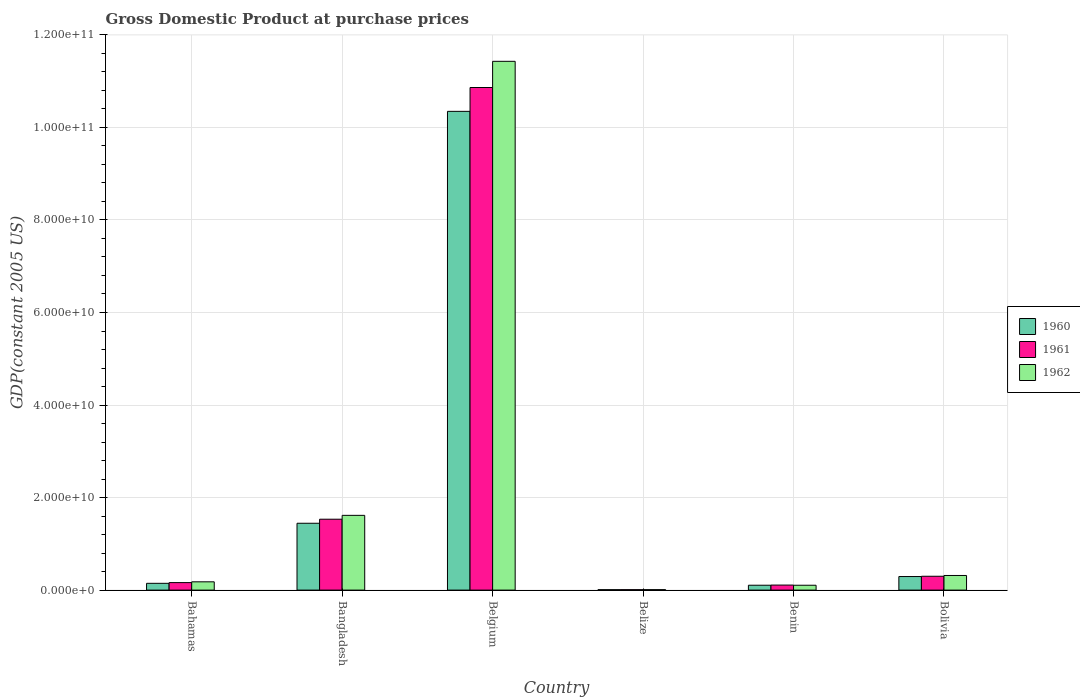How many different coloured bars are there?
Provide a succinct answer. 3. How many groups of bars are there?
Your answer should be very brief. 6. Are the number of bars per tick equal to the number of legend labels?
Make the answer very short. Yes. How many bars are there on the 3rd tick from the left?
Provide a succinct answer. 3. In how many cases, is the number of bars for a given country not equal to the number of legend labels?
Keep it short and to the point. 0. What is the GDP at purchase prices in 1960 in Bangladesh?
Your answer should be compact. 1.44e+1. Across all countries, what is the maximum GDP at purchase prices in 1962?
Provide a succinct answer. 1.14e+11. Across all countries, what is the minimum GDP at purchase prices in 1960?
Keep it short and to the point. 8.94e+07. In which country was the GDP at purchase prices in 1960 maximum?
Make the answer very short. Belgium. In which country was the GDP at purchase prices in 1962 minimum?
Offer a very short reply. Belize. What is the total GDP at purchase prices in 1962 in the graph?
Offer a terse response. 1.37e+11. What is the difference between the GDP at purchase prices in 1960 in Belize and that in Benin?
Keep it short and to the point. -9.64e+08. What is the difference between the GDP at purchase prices in 1960 in Belize and the GDP at purchase prices in 1962 in Bahamas?
Keep it short and to the point. -1.70e+09. What is the average GDP at purchase prices in 1962 per country?
Ensure brevity in your answer.  2.28e+1. What is the difference between the GDP at purchase prices of/in 1960 and GDP at purchase prices of/in 1961 in Belize?
Make the answer very short. -4.38e+06. What is the ratio of the GDP at purchase prices in 1961 in Belize to that in Benin?
Your response must be concise. 0.09. Is the difference between the GDP at purchase prices in 1960 in Bahamas and Bangladesh greater than the difference between the GDP at purchase prices in 1961 in Bahamas and Bangladesh?
Give a very brief answer. Yes. What is the difference between the highest and the second highest GDP at purchase prices in 1960?
Your response must be concise. -8.90e+1. What is the difference between the highest and the lowest GDP at purchase prices in 1962?
Keep it short and to the point. 1.14e+11. Is the sum of the GDP at purchase prices in 1961 in Belize and Bolivia greater than the maximum GDP at purchase prices in 1960 across all countries?
Make the answer very short. No. What does the 2nd bar from the left in Bolivia represents?
Your answer should be compact. 1961. Are all the bars in the graph horizontal?
Your answer should be compact. No. Are the values on the major ticks of Y-axis written in scientific E-notation?
Give a very brief answer. Yes. Does the graph contain any zero values?
Provide a succinct answer. No. How are the legend labels stacked?
Give a very brief answer. Vertical. What is the title of the graph?
Provide a succinct answer. Gross Domestic Product at purchase prices. Does "2008" appear as one of the legend labels in the graph?
Offer a terse response. No. What is the label or title of the X-axis?
Ensure brevity in your answer.  Country. What is the label or title of the Y-axis?
Your answer should be compact. GDP(constant 2005 US). What is the GDP(constant 2005 US) in 1960 in Bahamas?
Provide a short and direct response. 1.47e+09. What is the GDP(constant 2005 US) of 1961 in Bahamas?
Offer a very short reply. 1.62e+09. What is the GDP(constant 2005 US) of 1962 in Bahamas?
Give a very brief answer. 1.79e+09. What is the GDP(constant 2005 US) of 1960 in Bangladesh?
Your response must be concise. 1.44e+1. What is the GDP(constant 2005 US) in 1961 in Bangladesh?
Provide a succinct answer. 1.53e+1. What is the GDP(constant 2005 US) in 1962 in Bangladesh?
Offer a terse response. 1.62e+1. What is the GDP(constant 2005 US) of 1960 in Belgium?
Your answer should be compact. 1.03e+11. What is the GDP(constant 2005 US) of 1961 in Belgium?
Provide a succinct answer. 1.09e+11. What is the GDP(constant 2005 US) in 1962 in Belgium?
Make the answer very short. 1.14e+11. What is the GDP(constant 2005 US) of 1960 in Belize?
Keep it short and to the point. 8.94e+07. What is the GDP(constant 2005 US) in 1961 in Belize?
Ensure brevity in your answer.  9.38e+07. What is the GDP(constant 2005 US) of 1962 in Belize?
Your answer should be very brief. 9.84e+07. What is the GDP(constant 2005 US) of 1960 in Benin?
Ensure brevity in your answer.  1.05e+09. What is the GDP(constant 2005 US) in 1961 in Benin?
Give a very brief answer. 1.09e+09. What is the GDP(constant 2005 US) in 1962 in Benin?
Your answer should be very brief. 1.05e+09. What is the GDP(constant 2005 US) in 1960 in Bolivia?
Keep it short and to the point. 2.93e+09. What is the GDP(constant 2005 US) of 1961 in Bolivia?
Keep it short and to the point. 2.99e+09. What is the GDP(constant 2005 US) in 1962 in Bolivia?
Provide a succinct answer. 3.16e+09. Across all countries, what is the maximum GDP(constant 2005 US) of 1960?
Your response must be concise. 1.03e+11. Across all countries, what is the maximum GDP(constant 2005 US) in 1961?
Offer a terse response. 1.09e+11. Across all countries, what is the maximum GDP(constant 2005 US) in 1962?
Your answer should be compact. 1.14e+11. Across all countries, what is the minimum GDP(constant 2005 US) in 1960?
Provide a succinct answer. 8.94e+07. Across all countries, what is the minimum GDP(constant 2005 US) in 1961?
Provide a succinct answer. 9.38e+07. Across all countries, what is the minimum GDP(constant 2005 US) of 1962?
Offer a very short reply. 9.84e+07. What is the total GDP(constant 2005 US) of 1960 in the graph?
Make the answer very short. 1.23e+11. What is the total GDP(constant 2005 US) in 1961 in the graph?
Your answer should be very brief. 1.30e+11. What is the total GDP(constant 2005 US) of 1962 in the graph?
Your response must be concise. 1.37e+11. What is the difference between the GDP(constant 2005 US) in 1960 in Bahamas and that in Bangladesh?
Your answer should be compact. -1.30e+1. What is the difference between the GDP(constant 2005 US) in 1961 in Bahamas and that in Bangladesh?
Your answer should be very brief. -1.37e+1. What is the difference between the GDP(constant 2005 US) of 1962 in Bahamas and that in Bangladesh?
Your answer should be compact. -1.44e+1. What is the difference between the GDP(constant 2005 US) in 1960 in Bahamas and that in Belgium?
Keep it short and to the point. -1.02e+11. What is the difference between the GDP(constant 2005 US) of 1961 in Bahamas and that in Belgium?
Offer a very short reply. -1.07e+11. What is the difference between the GDP(constant 2005 US) of 1962 in Bahamas and that in Belgium?
Provide a succinct answer. -1.12e+11. What is the difference between the GDP(constant 2005 US) in 1960 in Bahamas and that in Belize?
Your answer should be compact. 1.38e+09. What is the difference between the GDP(constant 2005 US) in 1961 in Bahamas and that in Belize?
Your response must be concise. 1.53e+09. What is the difference between the GDP(constant 2005 US) in 1962 in Bahamas and that in Belize?
Give a very brief answer. 1.69e+09. What is the difference between the GDP(constant 2005 US) of 1960 in Bahamas and that in Benin?
Keep it short and to the point. 4.13e+08. What is the difference between the GDP(constant 2005 US) in 1961 in Bahamas and that in Benin?
Ensure brevity in your answer.  5.36e+08. What is the difference between the GDP(constant 2005 US) in 1962 in Bahamas and that in Benin?
Provide a succinct answer. 7.43e+08. What is the difference between the GDP(constant 2005 US) of 1960 in Bahamas and that in Bolivia?
Provide a short and direct response. -1.47e+09. What is the difference between the GDP(constant 2005 US) of 1961 in Bahamas and that in Bolivia?
Make the answer very short. -1.37e+09. What is the difference between the GDP(constant 2005 US) in 1962 in Bahamas and that in Bolivia?
Give a very brief answer. -1.37e+09. What is the difference between the GDP(constant 2005 US) of 1960 in Bangladesh and that in Belgium?
Ensure brevity in your answer.  -8.90e+1. What is the difference between the GDP(constant 2005 US) of 1961 in Bangladesh and that in Belgium?
Your answer should be very brief. -9.33e+1. What is the difference between the GDP(constant 2005 US) in 1962 in Bangladesh and that in Belgium?
Make the answer very short. -9.81e+1. What is the difference between the GDP(constant 2005 US) in 1960 in Bangladesh and that in Belize?
Offer a terse response. 1.44e+1. What is the difference between the GDP(constant 2005 US) in 1961 in Bangladesh and that in Belize?
Give a very brief answer. 1.52e+1. What is the difference between the GDP(constant 2005 US) of 1962 in Bangladesh and that in Belize?
Keep it short and to the point. 1.61e+1. What is the difference between the GDP(constant 2005 US) in 1960 in Bangladesh and that in Benin?
Provide a short and direct response. 1.34e+1. What is the difference between the GDP(constant 2005 US) of 1961 in Bangladesh and that in Benin?
Keep it short and to the point. 1.42e+1. What is the difference between the GDP(constant 2005 US) in 1962 in Bangladesh and that in Benin?
Make the answer very short. 1.51e+1. What is the difference between the GDP(constant 2005 US) of 1960 in Bangladesh and that in Bolivia?
Make the answer very short. 1.15e+1. What is the difference between the GDP(constant 2005 US) in 1961 in Bangladesh and that in Bolivia?
Offer a very short reply. 1.23e+1. What is the difference between the GDP(constant 2005 US) of 1962 in Bangladesh and that in Bolivia?
Your answer should be very brief. 1.30e+1. What is the difference between the GDP(constant 2005 US) in 1960 in Belgium and that in Belize?
Provide a succinct answer. 1.03e+11. What is the difference between the GDP(constant 2005 US) in 1961 in Belgium and that in Belize?
Provide a short and direct response. 1.09e+11. What is the difference between the GDP(constant 2005 US) in 1962 in Belgium and that in Belize?
Keep it short and to the point. 1.14e+11. What is the difference between the GDP(constant 2005 US) of 1960 in Belgium and that in Benin?
Your answer should be very brief. 1.02e+11. What is the difference between the GDP(constant 2005 US) in 1961 in Belgium and that in Benin?
Provide a short and direct response. 1.08e+11. What is the difference between the GDP(constant 2005 US) in 1962 in Belgium and that in Benin?
Your response must be concise. 1.13e+11. What is the difference between the GDP(constant 2005 US) of 1960 in Belgium and that in Bolivia?
Ensure brevity in your answer.  1.01e+11. What is the difference between the GDP(constant 2005 US) in 1961 in Belgium and that in Bolivia?
Your answer should be compact. 1.06e+11. What is the difference between the GDP(constant 2005 US) in 1962 in Belgium and that in Bolivia?
Give a very brief answer. 1.11e+11. What is the difference between the GDP(constant 2005 US) of 1960 in Belize and that in Benin?
Offer a terse response. -9.64e+08. What is the difference between the GDP(constant 2005 US) of 1961 in Belize and that in Benin?
Provide a short and direct response. -9.92e+08. What is the difference between the GDP(constant 2005 US) in 1962 in Belize and that in Benin?
Offer a very short reply. -9.50e+08. What is the difference between the GDP(constant 2005 US) of 1960 in Belize and that in Bolivia?
Provide a short and direct response. -2.84e+09. What is the difference between the GDP(constant 2005 US) of 1961 in Belize and that in Bolivia?
Offer a very short reply. -2.90e+09. What is the difference between the GDP(constant 2005 US) of 1962 in Belize and that in Bolivia?
Make the answer very short. -3.06e+09. What is the difference between the GDP(constant 2005 US) in 1960 in Benin and that in Bolivia?
Your answer should be very brief. -1.88e+09. What is the difference between the GDP(constant 2005 US) of 1961 in Benin and that in Bolivia?
Your answer should be very brief. -1.91e+09. What is the difference between the GDP(constant 2005 US) of 1962 in Benin and that in Bolivia?
Offer a terse response. -2.11e+09. What is the difference between the GDP(constant 2005 US) in 1960 in Bahamas and the GDP(constant 2005 US) in 1961 in Bangladesh?
Ensure brevity in your answer.  -1.39e+1. What is the difference between the GDP(constant 2005 US) of 1960 in Bahamas and the GDP(constant 2005 US) of 1962 in Bangladesh?
Ensure brevity in your answer.  -1.47e+1. What is the difference between the GDP(constant 2005 US) in 1961 in Bahamas and the GDP(constant 2005 US) in 1962 in Bangladesh?
Ensure brevity in your answer.  -1.45e+1. What is the difference between the GDP(constant 2005 US) of 1960 in Bahamas and the GDP(constant 2005 US) of 1961 in Belgium?
Ensure brevity in your answer.  -1.07e+11. What is the difference between the GDP(constant 2005 US) in 1960 in Bahamas and the GDP(constant 2005 US) in 1962 in Belgium?
Your response must be concise. -1.13e+11. What is the difference between the GDP(constant 2005 US) in 1961 in Bahamas and the GDP(constant 2005 US) in 1962 in Belgium?
Provide a succinct answer. -1.13e+11. What is the difference between the GDP(constant 2005 US) in 1960 in Bahamas and the GDP(constant 2005 US) in 1961 in Belize?
Your response must be concise. 1.37e+09. What is the difference between the GDP(constant 2005 US) in 1960 in Bahamas and the GDP(constant 2005 US) in 1962 in Belize?
Your answer should be compact. 1.37e+09. What is the difference between the GDP(constant 2005 US) of 1961 in Bahamas and the GDP(constant 2005 US) of 1962 in Belize?
Provide a succinct answer. 1.52e+09. What is the difference between the GDP(constant 2005 US) in 1960 in Bahamas and the GDP(constant 2005 US) in 1961 in Benin?
Provide a short and direct response. 3.79e+08. What is the difference between the GDP(constant 2005 US) in 1960 in Bahamas and the GDP(constant 2005 US) in 1962 in Benin?
Offer a terse response. 4.17e+08. What is the difference between the GDP(constant 2005 US) in 1961 in Bahamas and the GDP(constant 2005 US) in 1962 in Benin?
Your answer should be very brief. 5.73e+08. What is the difference between the GDP(constant 2005 US) in 1960 in Bahamas and the GDP(constant 2005 US) in 1961 in Bolivia?
Keep it short and to the point. -1.53e+09. What is the difference between the GDP(constant 2005 US) in 1960 in Bahamas and the GDP(constant 2005 US) in 1962 in Bolivia?
Keep it short and to the point. -1.69e+09. What is the difference between the GDP(constant 2005 US) of 1961 in Bahamas and the GDP(constant 2005 US) of 1962 in Bolivia?
Provide a succinct answer. -1.54e+09. What is the difference between the GDP(constant 2005 US) of 1960 in Bangladesh and the GDP(constant 2005 US) of 1961 in Belgium?
Provide a succinct answer. -9.42e+1. What is the difference between the GDP(constant 2005 US) of 1960 in Bangladesh and the GDP(constant 2005 US) of 1962 in Belgium?
Offer a terse response. -9.98e+1. What is the difference between the GDP(constant 2005 US) in 1961 in Bangladesh and the GDP(constant 2005 US) in 1962 in Belgium?
Provide a succinct answer. -9.90e+1. What is the difference between the GDP(constant 2005 US) of 1960 in Bangladesh and the GDP(constant 2005 US) of 1961 in Belize?
Provide a succinct answer. 1.44e+1. What is the difference between the GDP(constant 2005 US) in 1960 in Bangladesh and the GDP(constant 2005 US) in 1962 in Belize?
Ensure brevity in your answer.  1.43e+1. What is the difference between the GDP(constant 2005 US) of 1961 in Bangladesh and the GDP(constant 2005 US) of 1962 in Belize?
Make the answer very short. 1.52e+1. What is the difference between the GDP(constant 2005 US) in 1960 in Bangladesh and the GDP(constant 2005 US) in 1961 in Benin?
Make the answer very short. 1.34e+1. What is the difference between the GDP(constant 2005 US) in 1960 in Bangladesh and the GDP(constant 2005 US) in 1962 in Benin?
Provide a short and direct response. 1.34e+1. What is the difference between the GDP(constant 2005 US) in 1961 in Bangladesh and the GDP(constant 2005 US) in 1962 in Benin?
Provide a short and direct response. 1.43e+1. What is the difference between the GDP(constant 2005 US) in 1960 in Bangladesh and the GDP(constant 2005 US) in 1961 in Bolivia?
Provide a succinct answer. 1.15e+1. What is the difference between the GDP(constant 2005 US) in 1960 in Bangladesh and the GDP(constant 2005 US) in 1962 in Bolivia?
Your answer should be very brief. 1.13e+1. What is the difference between the GDP(constant 2005 US) in 1961 in Bangladesh and the GDP(constant 2005 US) in 1962 in Bolivia?
Offer a terse response. 1.22e+1. What is the difference between the GDP(constant 2005 US) of 1960 in Belgium and the GDP(constant 2005 US) of 1961 in Belize?
Offer a very short reply. 1.03e+11. What is the difference between the GDP(constant 2005 US) in 1960 in Belgium and the GDP(constant 2005 US) in 1962 in Belize?
Keep it short and to the point. 1.03e+11. What is the difference between the GDP(constant 2005 US) in 1961 in Belgium and the GDP(constant 2005 US) in 1962 in Belize?
Keep it short and to the point. 1.09e+11. What is the difference between the GDP(constant 2005 US) in 1960 in Belgium and the GDP(constant 2005 US) in 1961 in Benin?
Ensure brevity in your answer.  1.02e+11. What is the difference between the GDP(constant 2005 US) in 1960 in Belgium and the GDP(constant 2005 US) in 1962 in Benin?
Your answer should be very brief. 1.02e+11. What is the difference between the GDP(constant 2005 US) in 1961 in Belgium and the GDP(constant 2005 US) in 1962 in Benin?
Your answer should be compact. 1.08e+11. What is the difference between the GDP(constant 2005 US) in 1960 in Belgium and the GDP(constant 2005 US) in 1961 in Bolivia?
Your response must be concise. 1.00e+11. What is the difference between the GDP(constant 2005 US) in 1960 in Belgium and the GDP(constant 2005 US) in 1962 in Bolivia?
Your answer should be compact. 1.00e+11. What is the difference between the GDP(constant 2005 US) in 1961 in Belgium and the GDP(constant 2005 US) in 1962 in Bolivia?
Ensure brevity in your answer.  1.05e+11. What is the difference between the GDP(constant 2005 US) of 1960 in Belize and the GDP(constant 2005 US) of 1961 in Benin?
Keep it short and to the point. -9.97e+08. What is the difference between the GDP(constant 2005 US) in 1960 in Belize and the GDP(constant 2005 US) in 1962 in Benin?
Your answer should be compact. -9.59e+08. What is the difference between the GDP(constant 2005 US) of 1961 in Belize and the GDP(constant 2005 US) of 1962 in Benin?
Give a very brief answer. -9.55e+08. What is the difference between the GDP(constant 2005 US) in 1960 in Belize and the GDP(constant 2005 US) in 1961 in Bolivia?
Provide a succinct answer. -2.90e+09. What is the difference between the GDP(constant 2005 US) of 1960 in Belize and the GDP(constant 2005 US) of 1962 in Bolivia?
Keep it short and to the point. -3.07e+09. What is the difference between the GDP(constant 2005 US) in 1961 in Belize and the GDP(constant 2005 US) in 1962 in Bolivia?
Your response must be concise. -3.07e+09. What is the difference between the GDP(constant 2005 US) in 1960 in Benin and the GDP(constant 2005 US) in 1961 in Bolivia?
Keep it short and to the point. -1.94e+09. What is the difference between the GDP(constant 2005 US) in 1960 in Benin and the GDP(constant 2005 US) in 1962 in Bolivia?
Offer a very short reply. -2.11e+09. What is the difference between the GDP(constant 2005 US) of 1961 in Benin and the GDP(constant 2005 US) of 1962 in Bolivia?
Offer a terse response. -2.07e+09. What is the average GDP(constant 2005 US) in 1960 per country?
Your answer should be compact. 2.06e+1. What is the average GDP(constant 2005 US) in 1961 per country?
Your answer should be very brief. 2.16e+1. What is the average GDP(constant 2005 US) in 1962 per country?
Your answer should be compact. 2.28e+1. What is the difference between the GDP(constant 2005 US) in 1960 and GDP(constant 2005 US) in 1961 in Bahamas?
Offer a terse response. -1.56e+08. What is the difference between the GDP(constant 2005 US) of 1960 and GDP(constant 2005 US) of 1962 in Bahamas?
Offer a terse response. -3.26e+08. What is the difference between the GDP(constant 2005 US) of 1961 and GDP(constant 2005 US) of 1962 in Bahamas?
Keep it short and to the point. -1.70e+08. What is the difference between the GDP(constant 2005 US) of 1960 and GDP(constant 2005 US) of 1961 in Bangladesh?
Your response must be concise. -8.75e+08. What is the difference between the GDP(constant 2005 US) of 1960 and GDP(constant 2005 US) of 1962 in Bangladesh?
Provide a succinct answer. -1.71e+09. What is the difference between the GDP(constant 2005 US) of 1961 and GDP(constant 2005 US) of 1962 in Bangladesh?
Make the answer very short. -8.36e+08. What is the difference between the GDP(constant 2005 US) in 1960 and GDP(constant 2005 US) in 1961 in Belgium?
Give a very brief answer. -5.15e+09. What is the difference between the GDP(constant 2005 US) in 1960 and GDP(constant 2005 US) in 1962 in Belgium?
Provide a short and direct response. -1.08e+1. What is the difference between the GDP(constant 2005 US) of 1961 and GDP(constant 2005 US) of 1962 in Belgium?
Offer a very short reply. -5.66e+09. What is the difference between the GDP(constant 2005 US) of 1960 and GDP(constant 2005 US) of 1961 in Belize?
Provide a short and direct response. -4.38e+06. What is the difference between the GDP(constant 2005 US) in 1960 and GDP(constant 2005 US) in 1962 in Belize?
Give a very brief answer. -8.97e+06. What is the difference between the GDP(constant 2005 US) in 1961 and GDP(constant 2005 US) in 1962 in Belize?
Your answer should be compact. -4.59e+06. What is the difference between the GDP(constant 2005 US) of 1960 and GDP(constant 2005 US) of 1961 in Benin?
Offer a terse response. -3.31e+07. What is the difference between the GDP(constant 2005 US) in 1960 and GDP(constant 2005 US) in 1962 in Benin?
Provide a succinct answer. 4.14e+06. What is the difference between the GDP(constant 2005 US) in 1961 and GDP(constant 2005 US) in 1962 in Benin?
Make the answer very short. 3.72e+07. What is the difference between the GDP(constant 2005 US) of 1960 and GDP(constant 2005 US) of 1961 in Bolivia?
Provide a succinct answer. -6.10e+07. What is the difference between the GDP(constant 2005 US) of 1960 and GDP(constant 2005 US) of 1962 in Bolivia?
Provide a succinct answer. -2.28e+08. What is the difference between the GDP(constant 2005 US) of 1961 and GDP(constant 2005 US) of 1962 in Bolivia?
Your response must be concise. -1.67e+08. What is the ratio of the GDP(constant 2005 US) of 1960 in Bahamas to that in Bangladesh?
Your answer should be compact. 0.1. What is the ratio of the GDP(constant 2005 US) in 1961 in Bahamas to that in Bangladesh?
Give a very brief answer. 0.11. What is the ratio of the GDP(constant 2005 US) of 1962 in Bahamas to that in Bangladesh?
Give a very brief answer. 0.11. What is the ratio of the GDP(constant 2005 US) of 1960 in Bahamas to that in Belgium?
Offer a very short reply. 0.01. What is the ratio of the GDP(constant 2005 US) of 1961 in Bahamas to that in Belgium?
Ensure brevity in your answer.  0.01. What is the ratio of the GDP(constant 2005 US) of 1962 in Bahamas to that in Belgium?
Offer a very short reply. 0.02. What is the ratio of the GDP(constant 2005 US) in 1960 in Bahamas to that in Belize?
Offer a very short reply. 16.39. What is the ratio of the GDP(constant 2005 US) in 1961 in Bahamas to that in Belize?
Make the answer very short. 17.29. What is the ratio of the GDP(constant 2005 US) of 1962 in Bahamas to that in Belize?
Make the answer very short. 18.2. What is the ratio of the GDP(constant 2005 US) of 1960 in Bahamas to that in Benin?
Provide a short and direct response. 1.39. What is the ratio of the GDP(constant 2005 US) of 1961 in Bahamas to that in Benin?
Your answer should be very brief. 1.49. What is the ratio of the GDP(constant 2005 US) in 1962 in Bahamas to that in Benin?
Ensure brevity in your answer.  1.71. What is the ratio of the GDP(constant 2005 US) in 1960 in Bahamas to that in Bolivia?
Your answer should be compact. 0.5. What is the ratio of the GDP(constant 2005 US) of 1961 in Bahamas to that in Bolivia?
Your answer should be compact. 0.54. What is the ratio of the GDP(constant 2005 US) of 1962 in Bahamas to that in Bolivia?
Make the answer very short. 0.57. What is the ratio of the GDP(constant 2005 US) in 1960 in Bangladesh to that in Belgium?
Keep it short and to the point. 0.14. What is the ratio of the GDP(constant 2005 US) of 1961 in Bangladesh to that in Belgium?
Offer a terse response. 0.14. What is the ratio of the GDP(constant 2005 US) of 1962 in Bangladesh to that in Belgium?
Your answer should be compact. 0.14. What is the ratio of the GDP(constant 2005 US) in 1960 in Bangladesh to that in Belize?
Your response must be concise. 161.53. What is the ratio of the GDP(constant 2005 US) in 1961 in Bangladesh to that in Belize?
Your answer should be very brief. 163.33. What is the ratio of the GDP(constant 2005 US) of 1962 in Bangladesh to that in Belize?
Your answer should be compact. 164.2. What is the ratio of the GDP(constant 2005 US) of 1960 in Bangladesh to that in Benin?
Give a very brief answer. 13.72. What is the ratio of the GDP(constant 2005 US) in 1961 in Bangladesh to that in Benin?
Make the answer very short. 14.11. What is the ratio of the GDP(constant 2005 US) in 1962 in Bangladesh to that in Benin?
Your response must be concise. 15.4. What is the ratio of the GDP(constant 2005 US) of 1960 in Bangladesh to that in Bolivia?
Provide a succinct answer. 4.93. What is the ratio of the GDP(constant 2005 US) in 1961 in Bangladesh to that in Bolivia?
Give a very brief answer. 5.12. What is the ratio of the GDP(constant 2005 US) in 1962 in Bangladesh to that in Bolivia?
Offer a very short reply. 5.11. What is the ratio of the GDP(constant 2005 US) of 1960 in Belgium to that in Belize?
Give a very brief answer. 1156.97. What is the ratio of the GDP(constant 2005 US) in 1961 in Belgium to that in Belize?
Your answer should be compact. 1157.92. What is the ratio of the GDP(constant 2005 US) in 1962 in Belgium to that in Belize?
Your answer should be very brief. 1161.44. What is the ratio of the GDP(constant 2005 US) in 1960 in Belgium to that in Benin?
Offer a terse response. 98.27. What is the ratio of the GDP(constant 2005 US) of 1961 in Belgium to that in Benin?
Your answer should be compact. 100.02. What is the ratio of the GDP(constant 2005 US) of 1962 in Belgium to that in Benin?
Your response must be concise. 108.97. What is the ratio of the GDP(constant 2005 US) in 1960 in Belgium to that in Bolivia?
Provide a succinct answer. 35.3. What is the ratio of the GDP(constant 2005 US) in 1961 in Belgium to that in Bolivia?
Give a very brief answer. 36.3. What is the ratio of the GDP(constant 2005 US) in 1962 in Belgium to that in Bolivia?
Keep it short and to the point. 36.18. What is the ratio of the GDP(constant 2005 US) in 1960 in Belize to that in Benin?
Ensure brevity in your answer.  0.08. What is the ratio of the GDP(constant 2005 US) of 1961 in Belize to that in Benin?
Offer a terse response. 0.09. What is the ratio of the GDP(constant 2005 US) of 1962 in Belize to that in Benin?
Your response must be concise. 0.09. What is the ratio of the GDP(constant 2005 US) of 1960 in Belize to that in Bolivia?
Give a very brief answer. 0.03. What is the ratio of the GDP(constant 2005 US) in 1961 in Belize to that in Bolivia?
Offer a very short reply. 0.03. What is the ratio of the GDP(constant 2005 US) of 1962 in Belize to that in Bolivia?
Keep it short and to the point. 0.03. What is the ratio of the GDP(constant 2005 US) in 1960 in Benin to that in Bolivia?
Provide a succinct answer. 0.36. What is the ratio of the GDP(constant 2005 US) of 1961 in Benin to that in Bolivia?
Offer a very short reply. 0.36. What is the ratio of the GDP(constant 2005 US) in 1962 in Benin to that in Bolivia?
Keep it short and to the point. 0.33. What is the difference between the highest and the second highest GDP(constant 2005 US) in 1960?
Give a very brief answer. 8.90e+1. What is the difference between the highest and the second highest GDP(constant 2005 US) in 1961?
Your answer should be compact. 9.33e+1. What is the difference between the highest and the second highest GDP(constant 2005 US) in 1962?
Provide a short and direct response. 9.81e+1. What is the difference between the highest and the lowest GDP(constant 2005 US) in 1960?
Offer a terse response. 1.03e+11. What is the difference between the highest and the lowest GDP(constant 2005 US) in 1961?
Your response must be concise. 1.09e+11. What is the difference between the highest and the lowest GDP(constant 2005 US) of 1962?
Keep it short and to the point. 1.14e+11. 